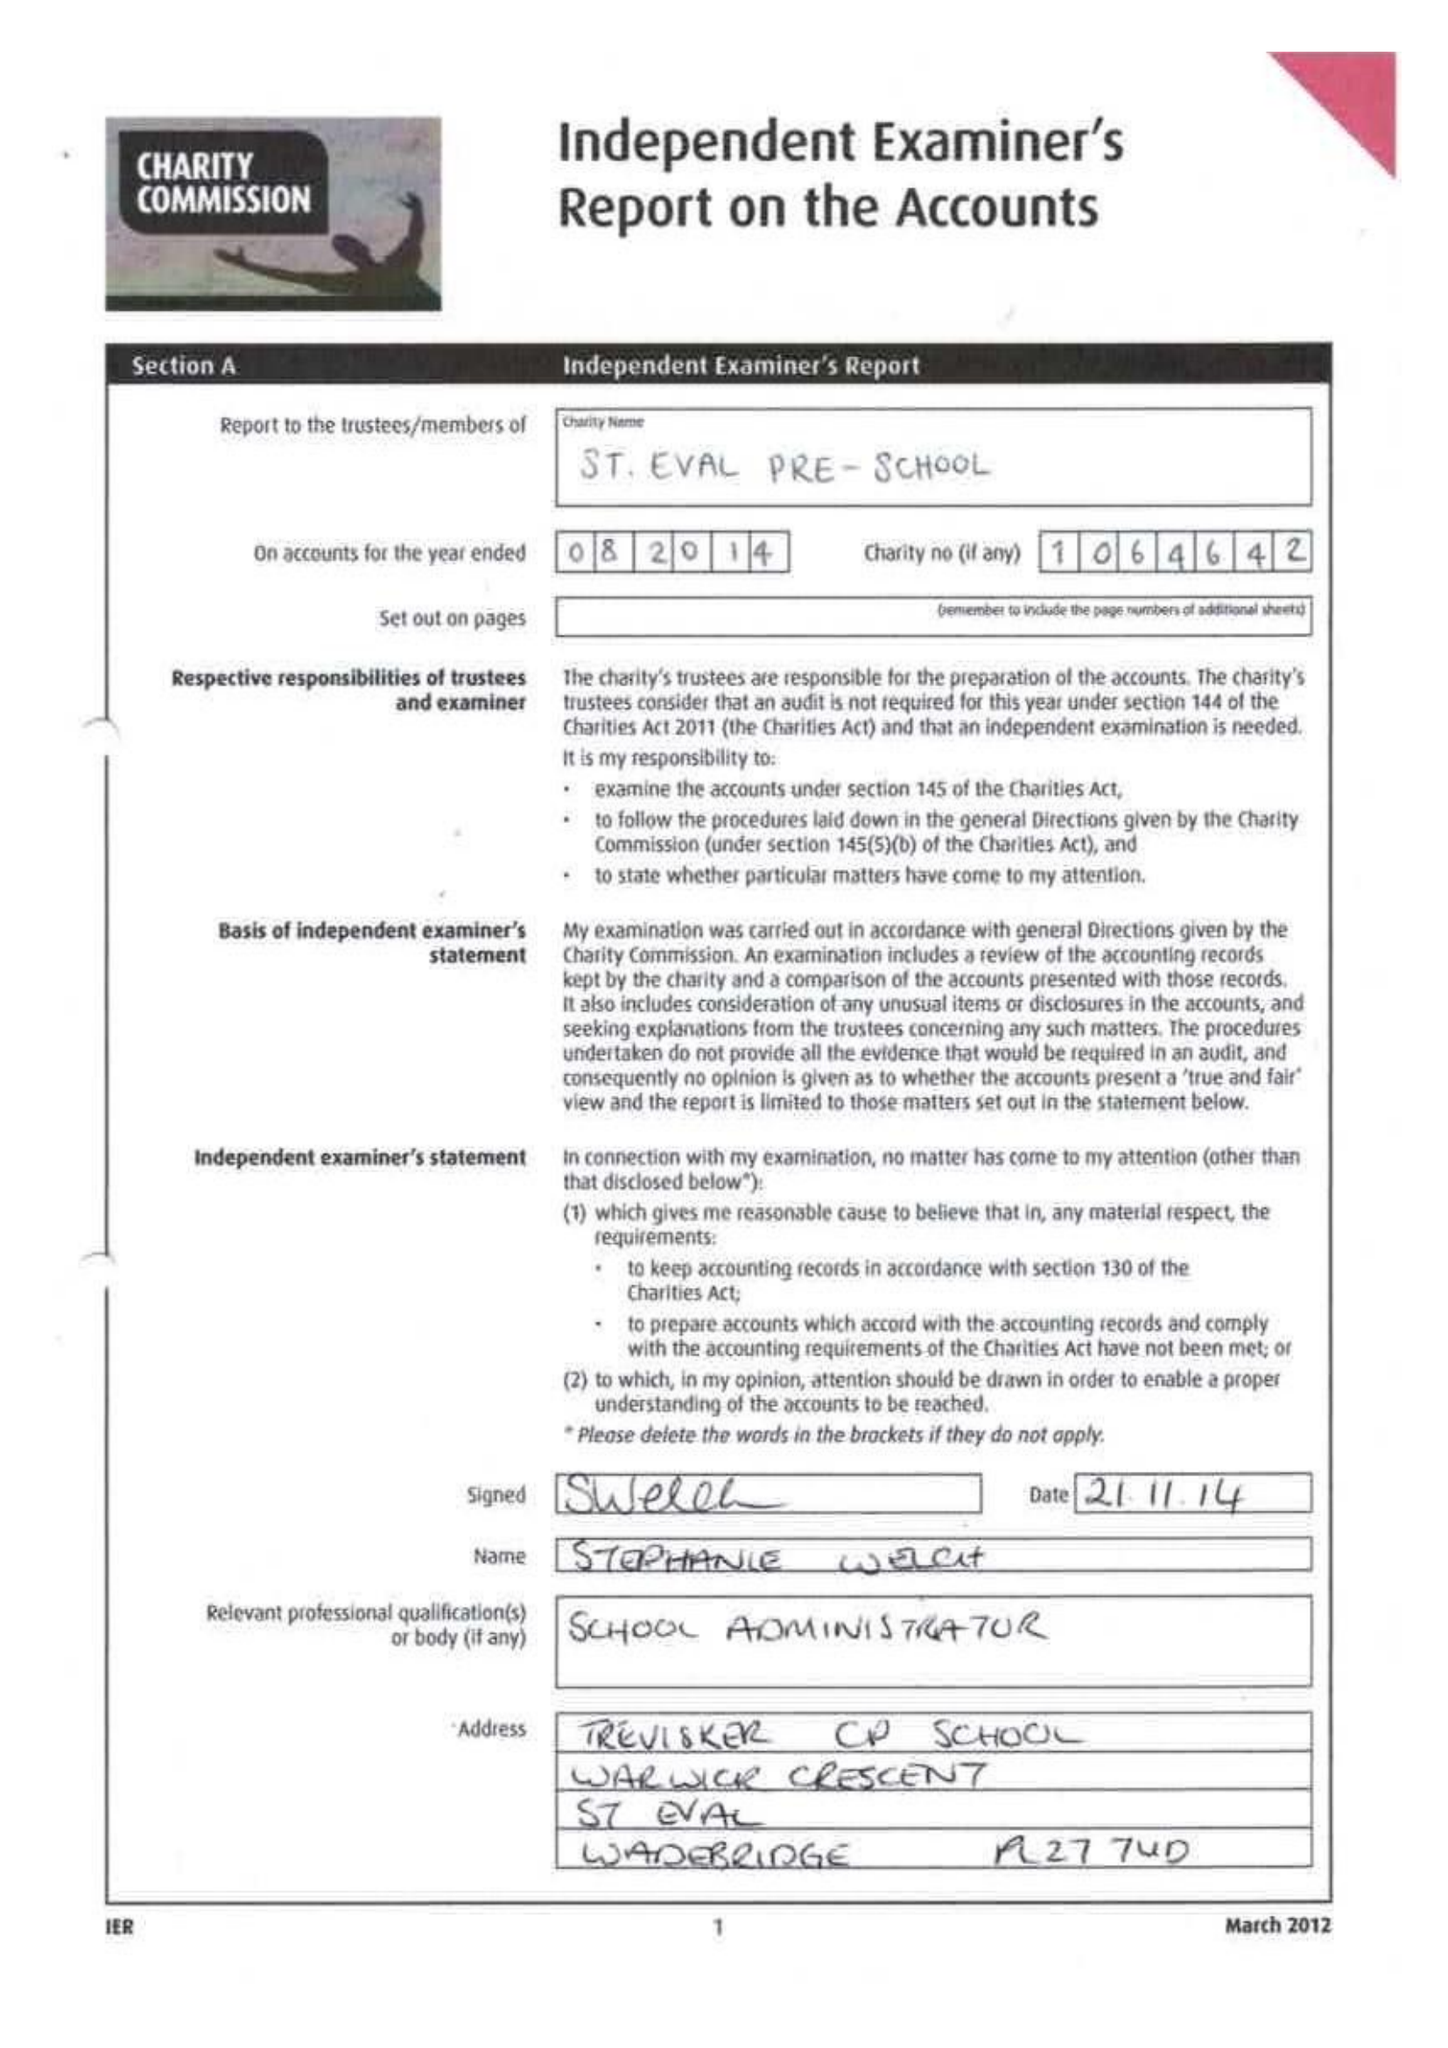What is the value for the income_annually_in_british_pounds?
Answer the question using a single word or phrase. 93124.18 